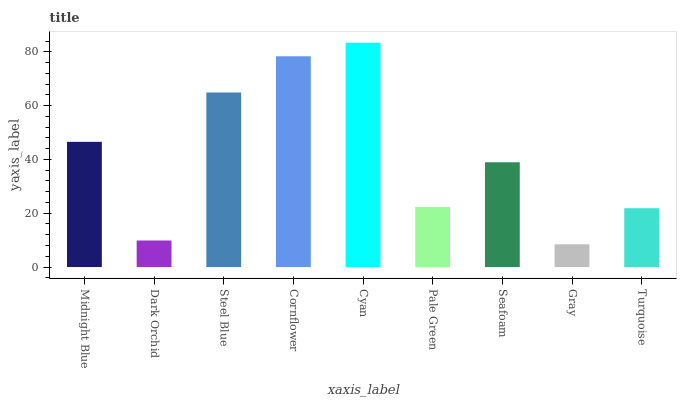Is Gray the minimum?
Answer yes or no. Yes. Is Cyan the maximum?
Answer yes or no. Yes. Is Dark Orchid the minimum?
Answer yes or no. No. Is Dark Orchid the maximum?
Answer yes or no. No. Is Midnight Blue greater than Dark Orchid?
Answer yes or no. Yes. Is Dark Orchid less than Midnight Blue?
Answer yes or no. Yes. Is Dark Orchid greater than Midnight Blue?
Answer yes or no. No. Is Midnight Blue less than Dark Orchid?
Answer yes or no. No. Is Seafoam the high median?
Answer yes or no. Yes. Is Seafoam the low median?
Answer yes or no. Yes. Is Cyan the high median?
Answer yes or no. No. Is Turquoise the low median?
Answer yes or no. No. 